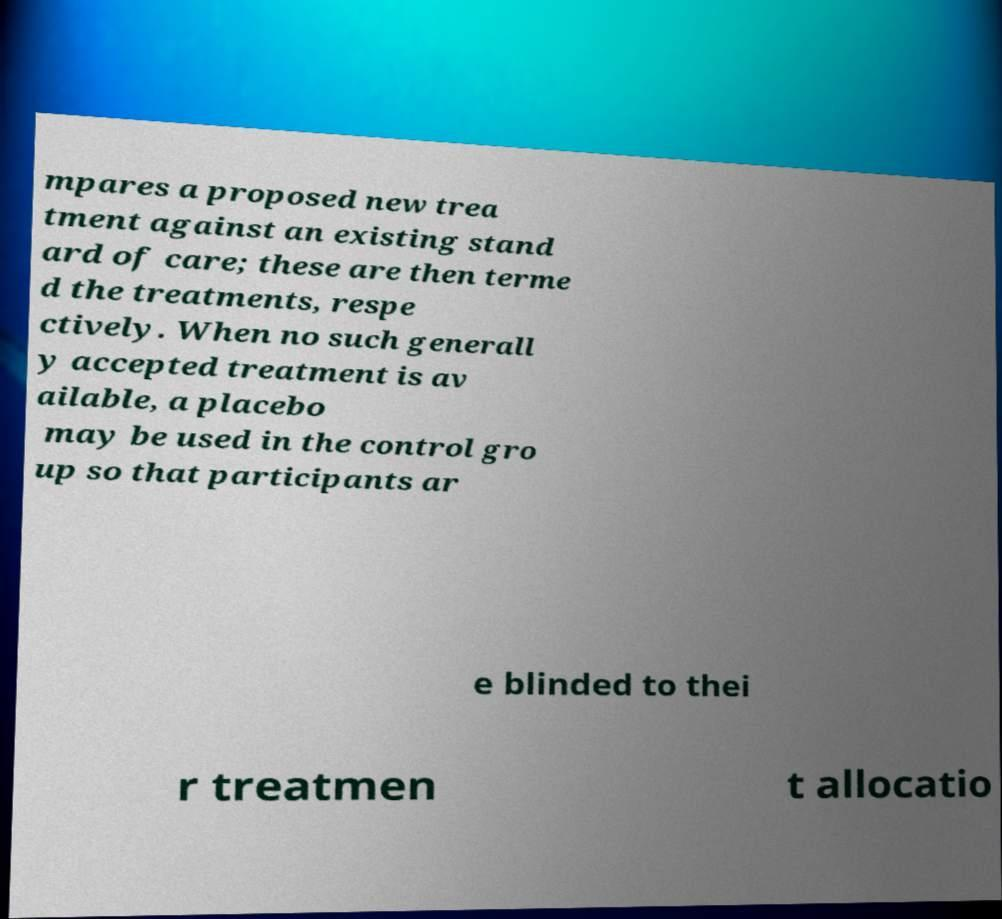Could you assist in decoding the text presented in this image and type it out clearly? mpares a proposed new trea tment against an existing stand ard of care; these are then terme d the treatments, respe ctively. When no such generall y accepted treatment is av ailable, a placebo may be used in the control gro up so that participants ar e blinded to thei r treatmen t allocatio 